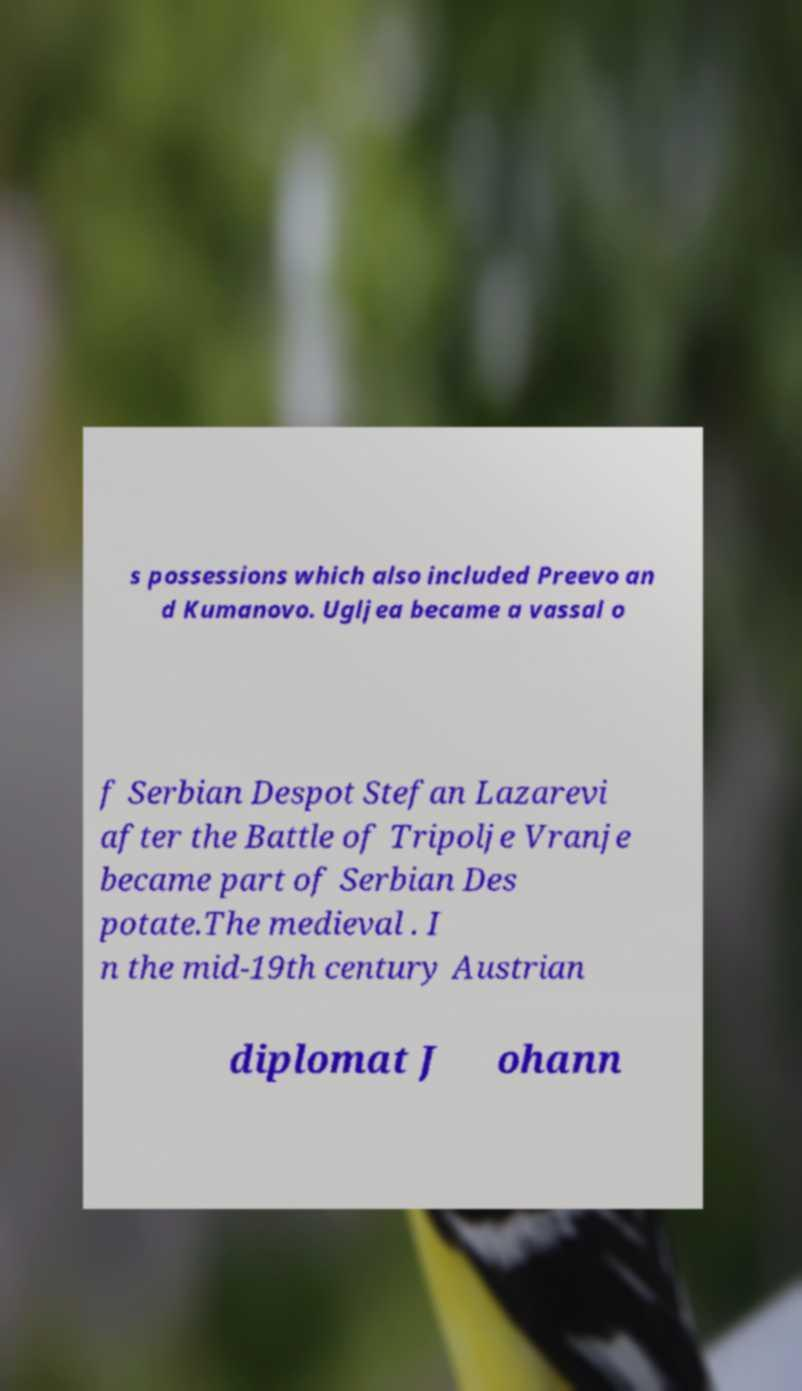Please identify and transcribe the text found in this image. s possessions which also included Preevo an d Kumanovo. Ugljea became a vassal o f Serbian Despot Stefan Lazarevi after the Battle of Tripolje Vranje became part of Serbian Des potate.The medieval . I n the mid-19th century Austrian diplomat J ohann 